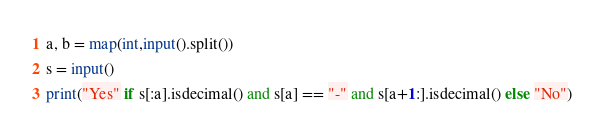<code> <loc_0><loc_0><loc_500><loc_500><_Python_>a, b = map(int,input().split())
s = input()
print("Yes" if s[:a].isdecimal() and s[a] == "-" and s[a+1:].isdecimal() else "No")</code> 